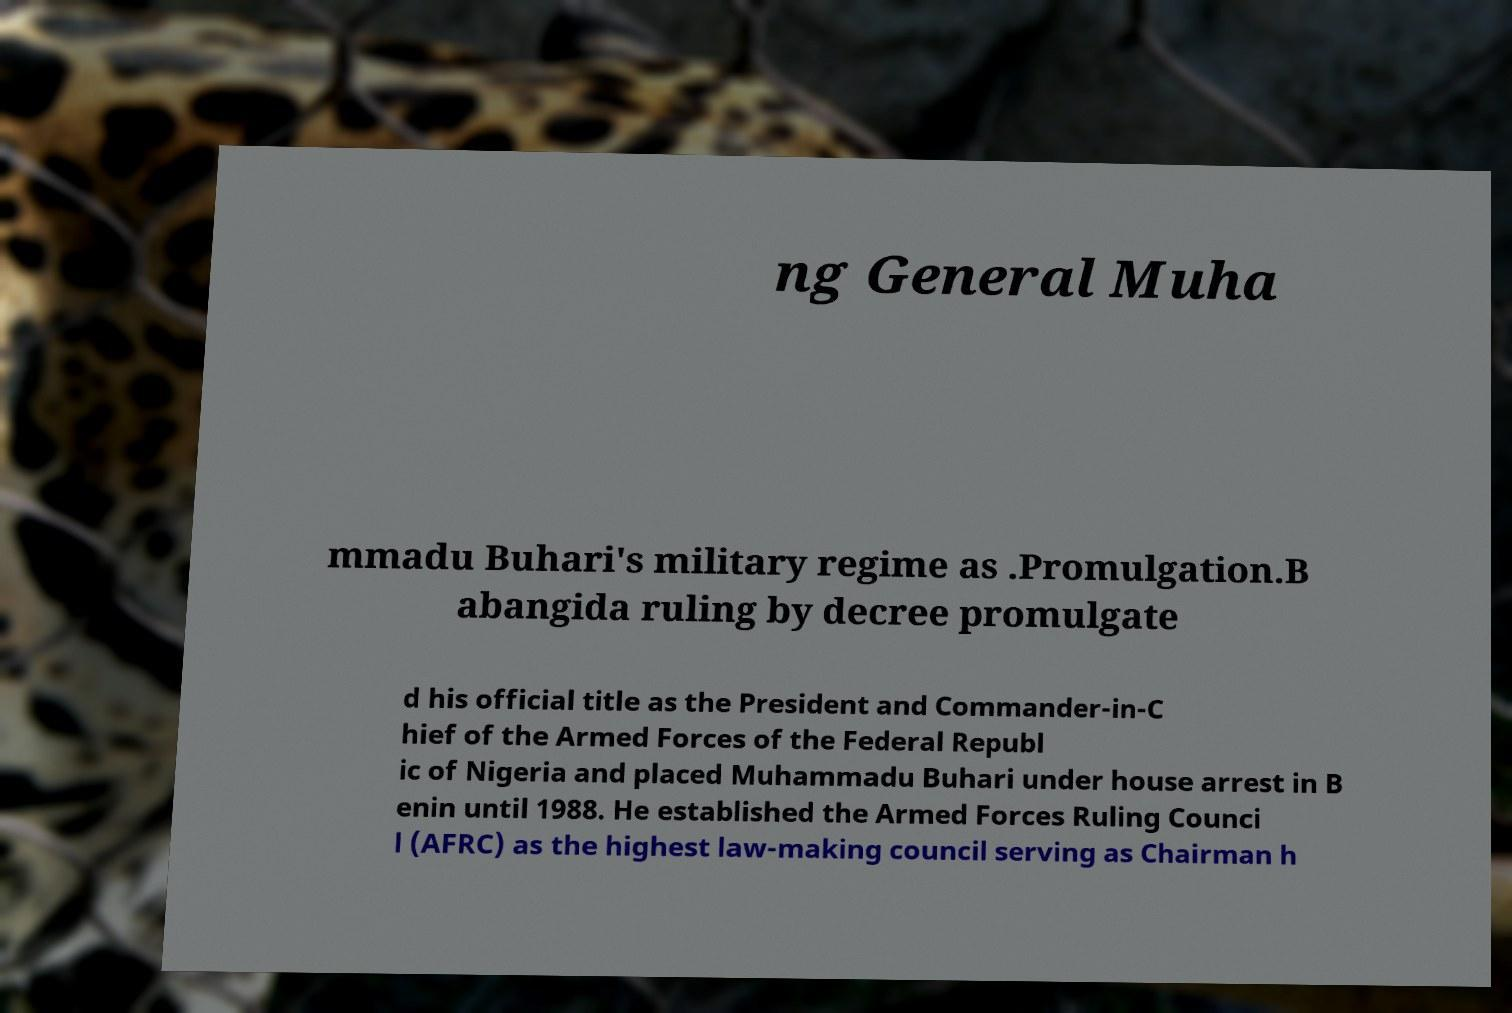Can you accurately transcribe the text from the provided image for me? ng General Muha mmadu Buhari's military regime as .Promulgation.B abangida ruling by decree promulgate d his official title as the President and Commander-in-C hief of the Armed Forces of the Federal Republ ic of Nigeria and placed Muhammadu Buhari under house arrest in B enin until 1988. He established the Armed Forces Ruling Counci l (AFRC) as the highest law-making council serving as Chairman h 